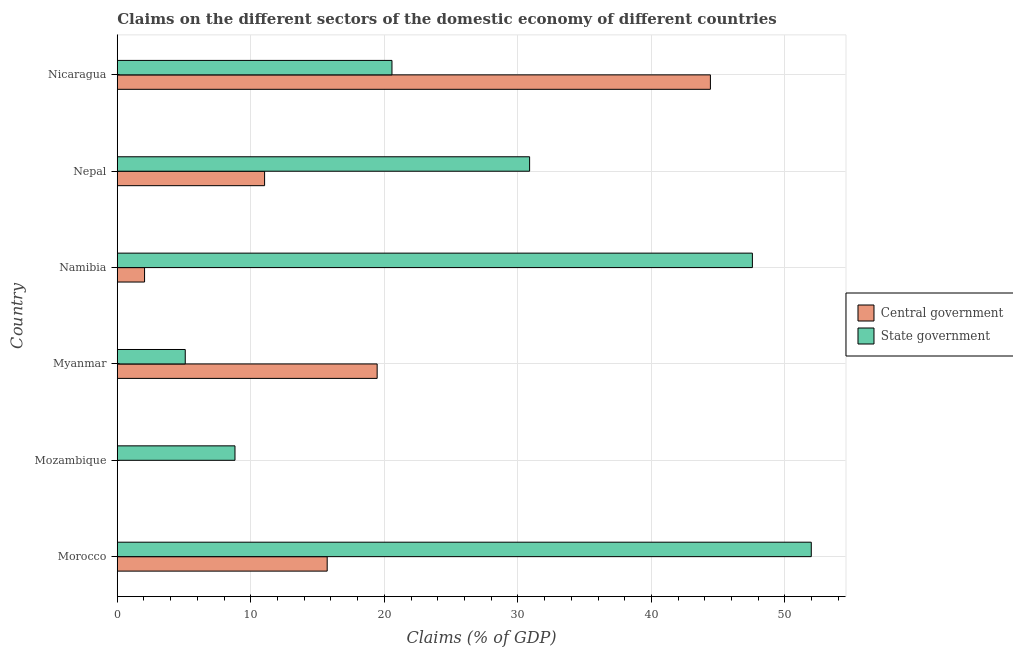Are the number of bars on each tick of the Y-axis equal?
Your answer should be compact. No. How many bars are there on the 1st tick from the top?
Your answer should be very brief. 2. What is the label of the 6th group of bars from the top?
Provide a short and direct response. Morocco. What is the claims on central government in Morocco?
Your answer should be very brief. 15.72. Across all countries, what is the maximum claims on central government?
Ensure brevity in your answer.  44.42. Across all countries, what is the minimum claims on state government?
Provide a succinct answer. 5.09. In which country was the claims on state government maximum?
Your response must be concise. Morocco. What is the total claims on state government in the graph?
Offer a terse response. 164.88. What is the difference between the claims on central government in Namibia and that in Nicaragua?
Your response must be concise. -42.37. What is the difference between the claims on central government in Mozambique and the claims on state government in Nicaragua?
Your response must be concise. -20.57. What is the average claims on state government per country?
Provide a short and direct response. 27.48. What is the difference between the claims on central government and claims on state government in Namibia?
Your response must be concise. -45.52. What is the ratio of the claims on state government in Myanmar to that in Nicaragua?
Provide a short and direct response. 0.25. What is the difference between the highest and the second highest claims on state government?
Give a very brief answer. 4.41. What is the difference between the highest and the lowest claims on state government?
Provide a short and direct response. 46.88. Is the sum of the claims on central government in Morocco and Nicaragua greater than the maximum claims on state government across all countries?
Your response must be concise. Yes. How many bars are there?
Your response must be concise. 11. What is the difference between two consecutive major ticks on the X-axis?
Keep it short and to the point. 10. Are the values on the major ticks of X-axis written in scientific E-notation?
Make the answer very short. No. Does the graph contain grids?
Your response must be concise. Yes. Where does the legend appear in the graph?
Provide a short and direct response. Center right. How are the legend labels stacked?
Provide a succinct answer. Vertical. What is the title of the graph?
Provide a short and direct response. Claims on the different sectors of the domestic economy of different countries. What is the label or title of the X-axis?
Offer a terse response. Claims (% of GDP). What is the label or title of the Y-axis?
Make the answer very short. Country. What is the Claims (% of GDP) in Central government in Morocco?
Provide a succinct answer. 15.72. What is the Claims (% of GDP) in State government in Morocco?
Your response must be concise. 51.97. What is the Claims (% of GDP) of Central government in Mozambique?
Provide a short and direct response. 0. What is the Claims (% of GDP) in State government in Mozambique?
Your answer should be very brief. 8.81. What is the Claims (% of GDP) in Central government in Myanmar?
Make the answer very short. 19.46. What is the Claims (% of GDP) of State government in Myanmar?
Provide a short and direct response. 5.09. What is the Claims (% of GDP) in Central government in Namibia?
Your answer should be very brief. 2.04. What is the Claims (% of GDP) in State government in Namibia?
Ensure brevity in your answer.  47.56. What is the Claims (% of GDP) of Central government in Nepal?
Keep it short and to the point. 11.03. What is the Claims (% of GDP) in State government in Nepal?
Keep it short and to the point. 30.88. What is the Claims (% of GDP) of Central government in Nicaragua?
Your answer should be compact. 44.42. What is the Claims (% of GDP) of State government in Nicaragua?
Ensure brevity in your answer.  20.57. Across all countries, what is the maximum Claims (% of GDP) in Central government?
Your answer should be very brief. 44.42. Across all countries, what is the maximum Claims (% of GDP) of State government?
Provide a succinct answer. 51.97. Across all countries, what is the minimum Claims (% of GDP) of Central government?
Make the answer very short. 0. Across all countries, what is the minimum Claims (% of GDP) of State government?
Offer a terse response. 5.09. What is the total Claims (% of GDP) in Central government in the graph?
Your response must be concise. 92.67. What is the total Claims (% of GDP) of State government in the graph?
Offer a terse response. 164.88. What is the difference between the Claims (% of GDP) of State government in Morocco and that in Mozambique?
Your response must be concise. 43.16. What is the difference between the Claims (% of GDP) in Central government in Morocco and that in Myanmar?
Offer a terse response. -3.74. What is the difference between the Claims (% of GDP) in State government in Morocco and that in Myanmar?
Provide a succinct answer. 46.88. What is the difference between the Claims (% of GDP) of Central government in Morocco and that in Namibia?
Keep it short and to the point. 13.68. What is the difference between the Claims (% of GDP) of State government in Morocco and that in Namibia?
Give a very brief answer. 4.41. What is the difference between the Claims (% of GDP) of Central government in Morocco and that in Nepal?
Provide a short and direct response. 4.69. What is the difference between the Claims (% of GDP) in State government in Morocco and that in Nepal?
Offer a terse response. 21.09. What is the difference between the Claims (% of GDP) of Central government in Morocco and that in Nicaragua?
Give a very brief answer. -28.7. What is the difference between the Claims (% of GDP) in State government in Morocco and that in Nicaragua?
Offer a very short reply. 31.4. What is the difference between the Claims (% of GDP) of State government in Mozambique and that in Myanmar?
Your response must be concise. 3.72. What is the difference between the Claims (% of GDP) in State government in Mozambique and that in Namibia?
Ensure brevity in your answer.  -38.75. What is the difference between the Claims (% of GDP) in State government in Mozambique and that in Nepal?
Your answer should be very brief. -22.06. What is the difference between the Claims (% of GDP) in State government in Mozambique and that in Nicaragua?
Offer a terse response. -11.76. What is the difference between the Claims (% of GDP) in Central government in Myanmar and that in Namibia?
Give a very brief answer. 17.42. What is the difference between the Claims (% of GDP) in State government in Myanmar and that in Namibia?
Your answer should be compact. -42.47. What is the difference between the Claims (% of GDP) in Central government in Myanmar and that in Nepal?
Give a very brief answer. 8.43. What is the difference between the Claims (% of GDP) in State government in Myanmar and that in Nepal?
Make the answer very short. -25.79. What is the difference between the Claims (% of GDP) of Central government in Myanmar and that in Nicaragua?
Keep it short and to the point. -24.96. What is the difference between the Claims (% of GDP) of State government in Myanmar and that in Nicaragua?
Offer a terse response. -15.48. What is the difference between the Claims (% of GDP) of Central government in Namibia and that in Nepal?
Make the answer very short. -8.99. What is the difference between the Claims (% of GDP) in State government in Namibia and that in Nepal?
Your response must be concise. 16.68. What is the difference between the Claims (% of GDP) in Central government in Namibia and that in Nicaragua?
Keep it short and to the point. -42.37. What is the difference between the Claims (% of GDP) of State government in Namibia and that in Nicaragua?
Offer a very short reply. 26.99. What is the difference between the Claims (% of GDP) of Central government in Nepal and that in Nicaragua?
Make the answer very short. -33.38. What is the difference between the Claims (% of GDP) of State government in Nepal and that in Nicaragua?
Keep it short and to the point. 10.31. What is the difference between the Claims (% of GDP) of Central government in Morocco and the Claims (% of GDP) of State government in Mozambique?
Your response must be concise. 6.9. What is the difference between the Claims (% of GDP) in Central government in Morocco and the Claims (% of GDP) in State government in Myanmar?
Give a very brief answer. 10.63. What is the difference between the Claims (% of GDP) in Central government in Morocco and the Claims (% of GDP) in State government in Namibia?
Your answer should be compact. -31.84. What is the difference between the Claims (% of GDP) in Central government in Morocco and the Claims (% of GDP) in State government in Nepal?
Ensure brevity in your answer.  -15.16. What is the difference between the Claims (% of GDP) of Central government in Morocco and the Claims (% of GDP) of State government in Nicaragua?
Give a very brief answer. -4.85. What is the difference between the Claims (% of GDP) of Central government in Myanmar and the Claims (% of GDP) of State government in Namibia?
Provide a succinct answer. -28.1. What is the difference between the Claims (% of GDP) of Central government in Myanmar and the Claims (% of GDP) of State government in Nepal?
Keep it short and to the point. -11.42. What is the difference between the Claims (% of GDP) in Central government in Myanmar and the Claims (% of GDP) in State government in Nicaragua?
Ensure brevity in your answer.  -1.11. What is the difference between the Claims (% of GDP) in Central government in Namibia and the Claims (% of GDP) in State government in Nepal?
Your response must be concise. -28.83. What is the difference between the Claims (% of GDP) in Central government in Namibia and the Claims (% of GDP) in State government in Nicaragua?
Provide a short and direct response. -18.53. What is the difference between the Claims (% of GDP) of Central government in Nepal and the Claims (% of GDP) of State government in Nicaragua?
Make the answer very short. -9.54. What is the average Claims (% of GDP) in Central government per country?
Offer a terse response. 15.45. What is the average Claims (% of GDP) in State government per country?
Make the answer very short. 27.48. What is the difference between the Claims (% of GDP) in Central government and Claims (% of GDP) in State government in Morocco?
Provide a short and direct response. -36.25. What is the difference between the Claims (% of GDP) in Central government and Claims (% of GDP) in State government in Myanmar?
Offer a terse response. 14.37. What is the difference between the Claims (% of GDP) in Central government and Claims (% of GDP) in State government in Namibia?
Your answer should be very brief. -45.52. What is the difference between the Claims (% of GDP) of Central government and Claims (% of GDP) of State government in Nepal?
Make the answer very short. -19.85. What is the difference between the Claims (% of GDP) of Central government and Claims (% of GDP) of State government in Nicaragua?
Provide a succinct answer. 23.85. What is the ratio of the Claims (% of GDP) of State government in Morocco to that in Mozambique?
Give a very brief answer. 5.9. What is the ratio of the Claims (% of GDP) of Central government in Morocco to that in Myanmar?
Provide a succinct answer. 0.81. What is the ratio of the Claims (% of GDP) of State government in Morocco to that in Myanmar?
Your answer should be very brief. 10.21. What is the ratio of the Claims (% of GDP) of Central government in Morocco to that in Namibia?
Provide a short and direct response. 7.7. What is the ratio of the Claims (% of GDP) in State government in Morocco to that in Namibia?
Keep it short and to the point. 1.09. What is the ratio of the Claims (% of GDP) in Central government in Morocco to that in Nepal?
Make the answer very short. 1.42. What is the ratio of the Claims (% of GDP) in State government in Morocco to that in Nepal?
Give a very brief answer. 1.68. What is the ratio of the Claims (% of GDP) of Central government in Morocco to that in Nicaragua?
Your answer should be compact. 0.35. What is the ratio of the Claims (% of GDP) of State government in Morocco to that in Nicaragua?
Your response must be concise. 2.53. What is the ratio of the Claims (% of GDP) of State government in Mozambique to that in Myanmar?
Make the answer very short. 1.73. What is the ratio of the Claims (% of GDP) in State government in Mozambique to that in Namibia?
Keep it short and to the point. 0.19. What is the ratio of the Claims (% of GDP) in State government in Mozambique to that in Nepal?
Your answer should be compact. 0.29. What is the ratio of the Claims (% of GDP) in State government in Mozambique to that in Nicaragua?
Ensure brevity in your answer.  0.43. What is the ratio of the Claims (% of GDP) of Central government in Myanmar to that in Namibia?
Make the answer very short. 9.53. What is the ratio of the Claims (% of GDP) of State government in Myanmar to that in Namibia?
Ensure brevity in your answer.  0.11. What is the ratio of the Claims (% of GDP) in Central government in Myanmar to that in Nepal?
Your answer should be very brief. 1.76. What is the ratio of the Claims (% of GDP) of State government in Myanmar to that in Nepal?
Make the answer very short. 0.16. What is the ratio of the Claims (% of GDP) in Central government in Myanmar to that in Nicaragua?
Ensure brevity in your answer.  0.44. What is the ratio of the Claims (% of GDP) in State government in Myanmar to that in Nicaragua?
Give a very brief answer. 0.25. What is the ratio of the Claims (% of GDP) in Central government in Namibia to that in Nepal?
Offer a very short reply. 0.19. What is the ratio of the Claims (% of GDP) in State government in Namibia to that in Nepal?
Keep it short and to the point. 1.54. What is the ratio of the Claims (% of GDP) of Central government in Namibia to that in Nicaragua?
Offer a terse response. 0.05. What is the ratio of the Claims (% of GDP) of State government in Namibia to that in Nicaragua?
Give a very brief answer. 2.31. What is the ratio of the Claims (% of GDP) of Central government in Nepal to that in Nicaragua?
Keep it short and to the point. 0.25. What is the ratio of the Claims (% of GDP) of State government in Nepal to that in Nicaragua?
Your answer should be compact. 1.5. What is the difference between the highest and the second highest Claims (% of GDP) of Central government?
Your answer should be very brief. 24.96. What is the difference between the highest and the second highest Claims (% of GDP) of State government?
Keep it short and to the point. 4.41. What is the difference between the highest and the lowest Claims (% of GDP) in Central government?
Your answer should be compact. 44.42. What is the difference between the highest and the lowest Claims (% of GDP) of State government?
Give a very brief answer. 46.88. 